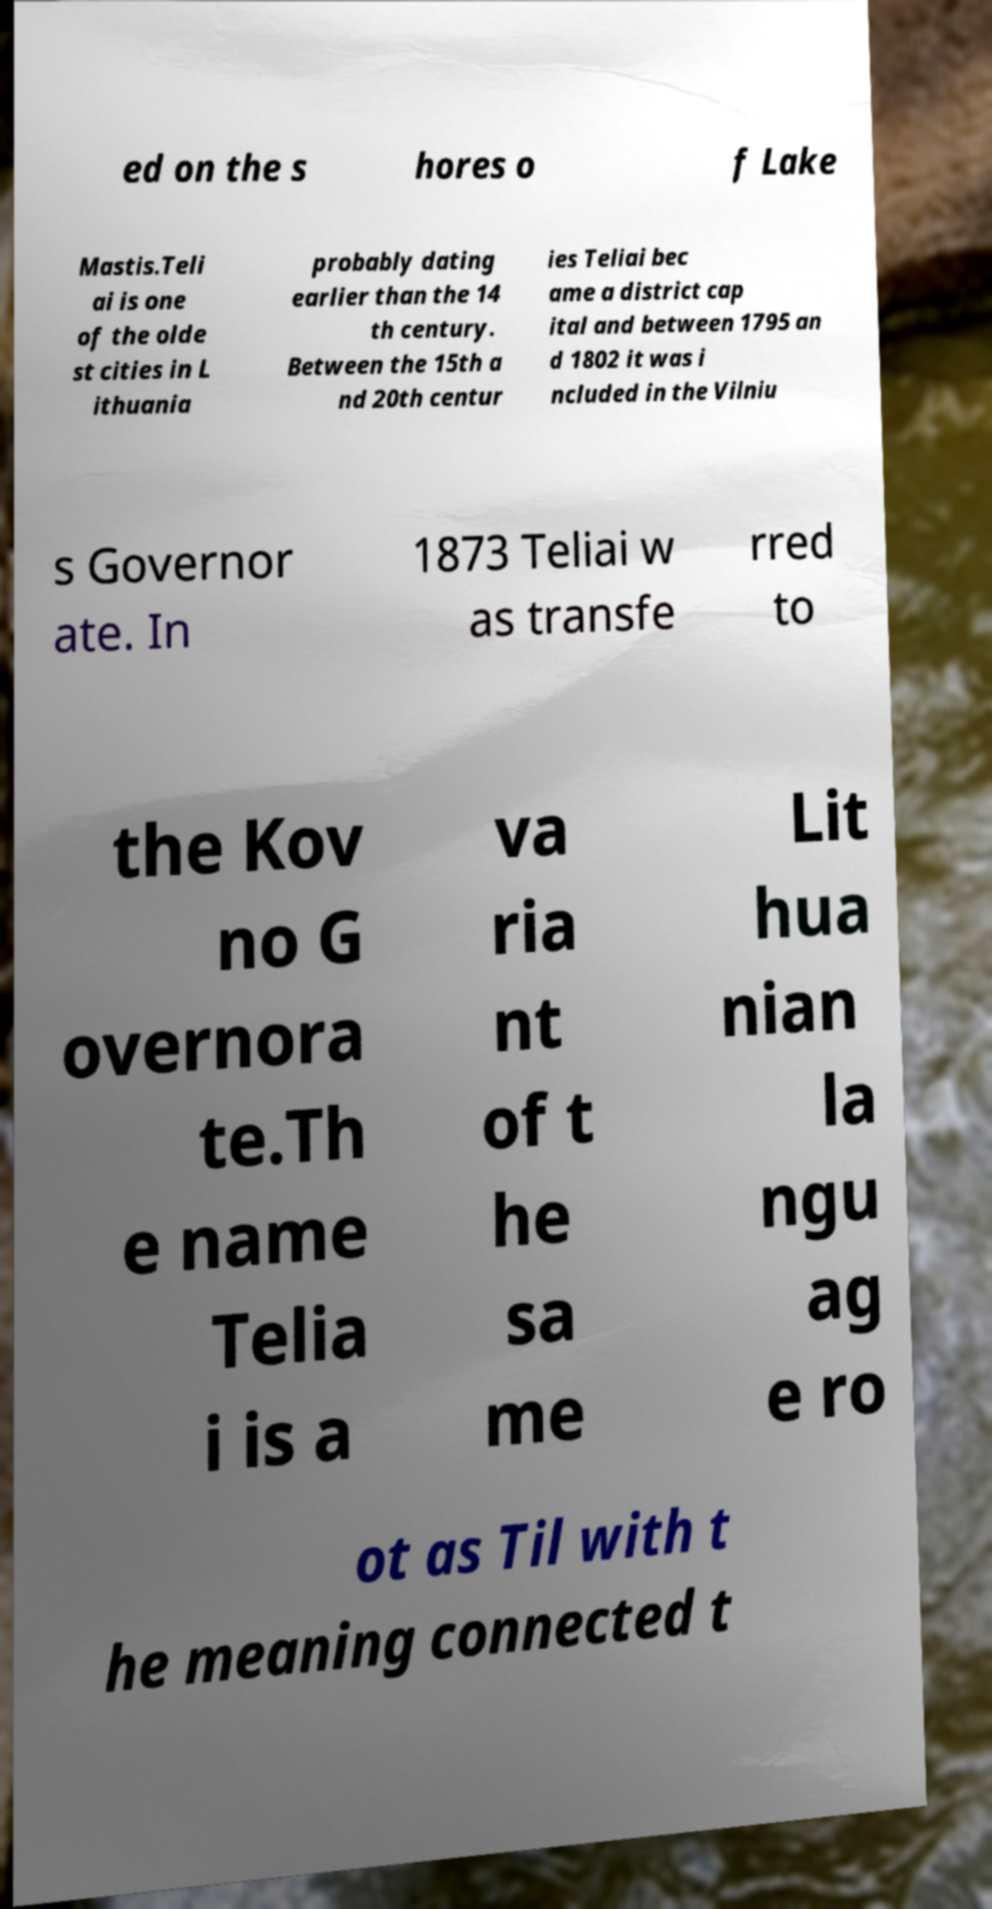For documentation purposes, I need the text within this image transcribed. Could you provide that? ed on the s hores o f Lake Mastis.Teli ai is one of the olde st cities in L ithuania probably dating earlier than the 14 th century. Between the 15th a nd 20th centur ies Teliai bec ame a district cap ital and between 1795 an d 1802 it was i ncluded in the Vilniu s Governor ate. In 1873 Teliai w as transfe rred to the Kov no G overnora te.Th e name Telia i is a va ria nt of t he sa me Lit hua nian la ngu ag e ro ot as Til with t he meaning connected t 